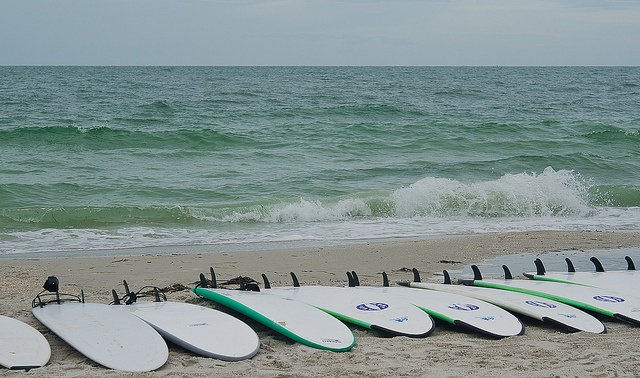Describe the objects in this image and their specific colors. I can see surfboard in darkgray, lightgray, and black tones, surfboard in darkgray, lightgray, and gray tones, surfboard in darkgray, lightgray, and black tones, surfboard in darkgray, lightgray, teal, and black tones, and surfboard in darkgray, lightgray, and black tones in this image. 